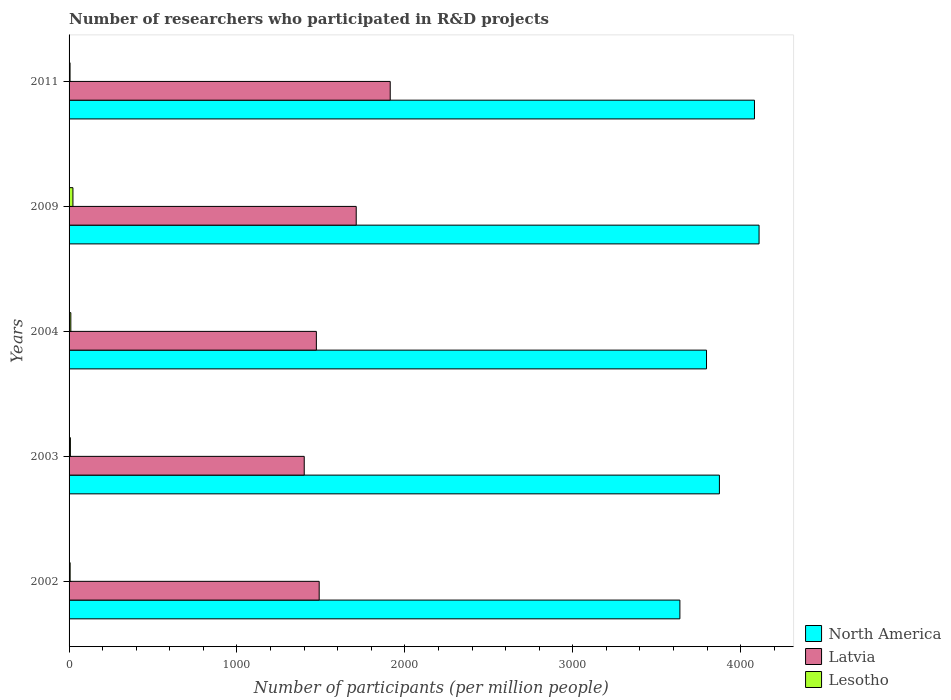How many groups of bars are there?
Ensure brevity in your answer.  5. Are the number of bars per tick equal to the number of legend labels?
Offer a terse response. Yes. Are the number of bars on each tick of the Y-axis equal?
Keep it short and to the point. Yes. How many bars are there on the 5th tick from the bottom?
Make the answer very short. 3. What is the label of the 3rd group of bars from the top?
Offer a very short reply. 2004. What is the number of researchers who participated in R&D projects in Latvia in 2004?
Your answer should be very brief. 1472.79. Across all years, what is the maximum number of researchers who participated in R&D projects in North America?
Your answer should be very brief. 4109.29. Across all years, what is the minimum number of researchers who participated in R&D projects in Lesotho?
Keep it short and to the point. 5.85. In which year was the number of researchers who participated in R&D projects in North America minimum?
Ensure brevity in your answer.  2002. What is the total number of researchers who participated in R&D projects in North America in the graph?
Provide a succinct answer. 1.95e+04. What is the difference between the number of researchers who participated in R&D projects in North America in 2004 and that in 2011?
Offer a very short reply. -285.58. What is the difference between the number of researchers who participated in R&D projects in North America in 2004 and the number of researchers who participated in R&D projects in Lesotho in 2009?
Provide a succinct answer. 3773.34. What is the average number of researchers who participated in R&D projects in Lesotho per year?
Your answer should be very brief. 10.72. In the year 2002, what is the difference between the number of researchers who participated in R&D projects in North America and number of researchers who participated in R&D projects in Latvia?
Give a very brief answer. 2148.18. What is the ratio of the number of researchers who participated in R&D projects in Lesotho in 2003 to that in 2009?
Provide a short and direct response. 0.34. What is the difference between the highest and the second highest number of researchers who participated in R&D projects in Latvia?
Ensure brevity in your answer.  202.43. What is the difference between the highest and the lowest number of researchers who participated in R&D projects in Latvia?
Provide a succinct answer. 512.06. In how many years, is the number of researchers who participated in R&D projects in Latvia greater than the average number of researchers who participated in R&D projects in Latvia taken over all years?
Your answer should be compact. 2. Are all the bars in the graph horizontal?
Your answer should be compact. Yes. How many years are there in the graph?
Keep it short and to the point. 5. What is the difference between two consecutive major ticks on the X-axis?
Make the answer very short. 1000. Does the graph contain any zero values?
Provide a short and direct response. No. How many legend labels are there?
Your response must be concise. 3. How are the legend labels stacked?
Give a very brief answer. Vertical. What is the title of the graph?
Offer a terse response. Number of researchers who participated in R&D projects. What is the label or title of the X-axis?
Provide a succinct answer. Number of participants (per million people). What is the Number of participants (per million people) in North America in 2002?
Offer a terse response. 3637.78. What is the Number of participants (per million people) of Latvia in 2002?
Provide a succinct answer. 1489.6. What is the Number of participants (per million people) of Lesotho in 2002?
Provide a succinct answer. 6.36. What is the Number of participants (per million people) of North America in 2003?
Ensure brevity in your answer.  3873.15. What is the Number of participants (per million people) in Latvia in 2003?
Ensure brevity in your answer.  1400.56. What is the Number of participants (per million people) in Lesotho in 2003?
Give a very brief answer. 7.9. What is the Number of participants (per million people) in North America in 2004?
Offer a terse response. 3796.35. What is the Number of participants (per million people) in Latvia in 2004?
Offer a terse response. 1472.79. What is the Number of participants (per million people) in Lesotho in 2004?
Your response must be concise. 10.46. What is the Number of participants (per million people) of North America in 2009?
Give a very brief answer. 4109.29. What is the Number of participants (per million people) in Latvia in 2009?
Keep it short and to the point. 1710.19. What is the Number of participants (per million people) in Lesotho in 2009?
Provide a succinct answer. 23.01. What is the Number of participants (per million people) in North America in 2011?
Ensure brevity in your answer.  4081.94. What is the Number of participants (per million people) of Latvia in 2011?
Your response must be concise. 1912.62. What is the Number of participants (per million people) in Lesotho in 2011?
Give a very brief answer. 5.85. Across all years, what is the maximum Number of participants (per million people) of North America?
Keep it short and to the point. 4109.29. Across all years, what is the maximum Number of participants (per million people) in Latvia?
Your answer should be compact. 1912.62. Across all years, what is the maximum Number of participants (per million people) in Lesotho?
Your answer should be compact. 23.01. Across all years, what is the minimum Number of participants (per million people) in North America?
Offer a very short reply. 3637.78. Across all years, what is the minimum Number of participants (per million people) in Latvia?
Keep it short and to the point. 1400.56. Across all years, what is the minimum Number of participants (per million people) in Lesotho?
Make the answer very short. 5.85. What is the total Number of participants (per million people) of North America in the graph?
Your answer should be compact. 1.95e+04. What is the total Number of participants (per million people) of Latvia in the graph?
Ensure brevity in your answer.  7985.76. What is the total Number of participants (per million people) in Lesotho in the graph?
Ensure brevity in your answer.  53.59. What is the difference between the Number of participants (per million people) in North America in 2002 and that in 2003?
Your answer should be very brief. -235.37. What is the difference between the Number of participants (per million people) in Latvia in 2002 and that in 2003?
Your response must be concise. 89.04. What is the difference between the Number of participants (per million people) of Lesotho in 2002 and that in 2003?
Give a very brief answer. -1.54. What is the difference between the Number of participants (per million people) in North America in 2002 and that in 2004?
Offer a terse response. -158.58. What is the difference between the Number of participants (per million people) of Latvia in 2002 and that in 2004?
Keep it short and to the point. 16.81. What is the difference between the Number of participants (per million people) of Lesotho in 2002 and that in 2004?
Make the answer very short. -4.1. What is the difference between the Number of participants (per million people) of North America in 2002 and that in 2009?
Ensure brevity in your answer.  -471.52. What is the difference between the Number of participants (per million people) of Latvia in 2002 and that in 2009?
Give a very brief answer. -220.59. What is the difference between the Number of participants (per million people) in Lesotho in 2002 and that in 2009?
Provide a short and direct response. -16.65. What is the difference between the Number of participants (per million people) of North America in 2002 and that in 2011?
Give a very brief answer. -444.16. What is the difference between the Number of participants (per million people) of Latvia in 2002 and that in 2011?
Keep it short and to the point. -423.02. What is the difference between the Number of participants (per million people) in Lesotho in 2002 and that in 2011?
Your response must be concise. 0.51. What is the difference between the Number of participants (per million people) of North America in 2003 and that in 2004?
Offer a very short reply. 76.79. What is the difference between the Number of participants (per million people) in Latvia in 2003 and that in 2004?
Your answer should be compact. -72.24. What is the difference between the Number of participants (per million people) in Lesotho in 2003 and that in 2004?
Make the answer very short. -2.56. What is the difference between the Number of participants (per million people) of North America in 2003 and that in 2009?
Provide a short and direct response. -236.14. What is the difference between the Number of participants (per million people) of Latvia in 2003 and that in 2009?
Offer a very short reply. -309.63. What is the difference between the Number of participants (per million people) of Lesotho in 2003 and that in 2009?
Provide a short and direct response. -15.11. What is the difference between the Number of participants (per million people) in North America in 2003 and that in 2011?
Your answer should be very brief. -208.79. What is the difference between the Number of participants (per million people) in Latvia in 2003 and that in 2011?
Your answer should be compact. -512.06. What is the difference between the Number of participants (per million people) in Lesotho in 2003 and that in 2011?
Your answer should be compact. 2.05. What is the difference between the Number of participants (per million people) of North America in 2004 and that in 2009?
Give a very brief answer. -312.94. What is the difference between the Number of participants (per million people) of Latvia in 2004 and that in 2009?
Make the answer very short. -237.4. What is the difference between the Number of participants (per million people) of Lesotho in 2004 and that in 2009?
Keep it short and to the point. -12.55. What is the difference between the Number of participants (per million people) of North America in 2004 and that in 2011?
Offer a terse response. -285.58. What is the difference between the Number of participants (per million people) in Latvia in 2004 and that in 2011?
Your response must be concise. -439.83. What is the difference between the Number of participants (per million people) of Lesotho in 2004 and that in 2011?
Ensure brevity in your answer.  4.61. What is the difference between the Number of participants (per million people) in North America in 2009 and that in 2011?
Provide a short and direct response. 27.36. What is the difference between the Number of participants (per million people) of Latvia in 2009 and that in 2011?
Your answer should be very brief. -202.43. What is the difference between the Number of participants (per million people) of Lesotho in 2009 and that in 2011?
Your answer should be compact. 17.16. What is the difference between the Number of participants (per million people) in North America in 2002 and the Number of participants (per million people) in Latvia in 2003?
Give a very brief answer. 2237.22. What is the difference between the Number of participants (per million people) of North America in 2002 and the Number of participants (per million people) of Lesotho in 2003?
Keep it short and to the point. 3629.88. What is the difference between the Number of participants (per million people) in Latvia in 2002 and the Number of participants (per million people) in Lesotho in 2003?
Your answer should be very brief. 1481.7. What is the difference between the Number of participants (per million people) in North America in 2002 and the Number of participants (per million people) in Latvia in 2004?
Give a very brief answer. 2164.98. What is the difference between the Number of participants (per million people) in North America in 2002 and the Number of participants (per million people) in Lesotho in 2004?
Make the answer very short. 3627.32. What is the difference between the Number of participants (per million people) in Latvia in 2002 and the Number of participants (per million people) in Lesotho in 2004?
Give a very brief answer. 1479.14. What is the difference between the Number of participants (per million people) in North America in 2002 and the Number of participants (per million people) in Latvia in 2009?
Give a very brief answer. 1927.59. What is the difference between the Number of participants (per million people) in North America in 2002 and the Number of participants (per million people) in Lesotho in 2009?
Provide a succinct answer. 3614.77. What is the difference between the Number of participants (per million people) in Latvia in 2002 and the Number of participants (per million people) in Lesotho in 2009?
Provide a succinct answer. 1466.59. What is the difference between the Number of participants (per million people) in North America in 2002 and the Number of participants (per million people) in Latvia in 2011?
Your answer should be compact. 1725.16. What is the difference between the Number of participants (per million people) in North America in 2002 and the Number of participants (per million people) in Lesotho in 2011?
Ensure brevity in your answer.  3631.92. What is the difference between the Number of participants (per million people) of Latvia in 2002 and the Number of participants (per million people) of Lesotho in 2011?
Offer a terse response. 1483.75. What is the difference between the Number of participants (per million people) in North America in 2003 and the Number of participants (per million people) in Latvia in 2004?
Make the answer very short. 2400.36. What is the difference between the Number of participants (per million people) of North America in 2003 and the Number of participants (per million people) of Lesotho in 2004?
Provide a succinct answer. 3862.69. What is the difference between the Number of participants (per million people) of Latvia in 2003 and the Number of participants (per million people) of Lesotho in 2004?
Your answer should be compact. 1390.1. What is the difference between the Number of participants (per million people) in North America in 2003 and the Number of participants (per million people) in Latvia in 2009?
Provide a short and direct response. 2162.96. What is the difference between the Number of participants (per million people) of North America in 2003 and the Number of participants (per million people) of Lesotho in 2009?
Give a very brief answer. 3850.14. What is the difference between the Number of participants (per million people) in Latvia in 2003 and the Number of participants (per million people) in Lesotho in 2009?
Give a very brief answer. 1377.55. What is the difference between the Number of participants (per million people) of North America in 2003 and the Number of participants (per million people) of Latvia in 2011?
Provide a succinct answer. 1960.53. What is the difference between the Number of participants (per million people) in North America in 2003 and the Number of participants (per million people) in Lesotho in 2011?
Keep it short and to the point. 3867.3. What is the difference between the Number of participants (per million people) of Latvia in 2003 and the Number of participants (per million people) of Lesotho in 2011?
Offer a terse response. 1394.7. What is the difference between the Number of participants (per million people) in North America in 2004 and the Number of participants (per million people) in Latvia in 2009?
Offer a very short reply. 2086.16. What is the difference between the Number of participants (per million people) of North America in 2004 and the Number of participants (per million people) of Lesotho in 2009?
Your answer should be compact. 3773.34. What is the difference between the Number of participants (per million people) of Latvia in 2004 and the Number of participants (per million people) of Lesotho in 2009?
Your answer should be compact. 1449.78. What is the difference between the Number of participants (per million people) of North America in 2004 and the Number of participants (per million people) of Latvia in 2011?
Keep it short and to the point. 1883.73. What is the difference between the Number of participants (per million people) of North America in 2004 and the Number of participants (per million people) of Lesotho in 2011?
Offer a very short reply. 3790.5. What is the difference between the Number of participants (per million people) in Latvia in 2004 and the Number of participants (per million people) in Lesotho in 2011?
Keep it short and to the point. 1466.94. What is the difference between the Number of participants (per million people) of North America in 2009 and the Number of participants (per million people) of Latvia in 2011?
Provide a succinct answer. 2196.67. What is the difference between the Number of participants (per million people) of North America in 2009 and the Number of participants (per million people) of Lesotho in 2011?
Give a very brief answer. 4103.44. What is the difference between the Number of participants (per million people) in Latvia in 2009 and the Number of participants (per million people) in Lesotho in 2011?
Provide a succinct answer. 1704.34. What is the average Number of participants (per million people) in North America per year?
Your answer should be very brief. 3899.7. What is the average Number of participants (per million people) of Latvia per year?
Give a very brief answer. 1597.15. What is the average Number of participants (per million people) in Lesotho per year?
Your response must be concise. 10.72. In the year 2002, what is the difference between the Number of participants (per million people) in North America and Number of participants (per million people) in Latvia?
Offer a terse response. 2148.18. In the year 2002, what is the difference between the Number of participants (per million people) in North America and Number of participants (per million people) in Lesotho?
Make the answer very short. 3631.41. In the year 2002, what is the difference between the Number of participants (per million people) in Latvia and Number of participants (per million people) in Lesotho?
Offer a terse response. 1483.23. In the year 2003, what is the difference between the Number of participants (per million people) in North America and Number of participants (per million people) in Latvia?
Ensure brevity in your answer.  2472.59. In the year 2003, what is the difference between the Number of participants (per million people) of North America and Number of participants (per million people) of Lesotho?
Ensure brevity in your answer.  3865.25. In the year 2003, what is the difference between the Number of participants (per million people) of Latvia and Number of participants (per million people) of Lesotho?
Give a very brief answer. 1392.66. In the year 2004, what is the difference between the Number of participants (per million people) in North America and Number of participants (per million people) in Latvia?
Your response must be concise. 2323.56. In the year 2004, what is the difference between the Number of participants (per million people) of North America and Number of participants (per million people) of Lesotho?
Your response must be concise. 3785.89. In the year 2004, what is the difference between the Number of participants (per million people) in Latvia and Number of participants (per million people) in Lesotho?
Your answer should be very brief. 1462.33. In the year 2009, what is the difference between the Number of participants (per million people) in North America and Number of participants (per million people) in Latvia?
Ensure brevity in your answer.  2399.1. In the year 2009, what is the difference between the Number of participants (per million people) in North America and Number of participants (per million people) in Lesotho?
Your response must be concise. 4086.28. In the year 2009, what is the difference between the Number of participants (per million people) in Latvia and Number of participants (per million people) in Lesotho?
Provide a succinct answer. 1687.18. In the year 2011, what is the difference between the Number of participants (per million people) in North America and Number of participants (per million people) in Latvia?
Your response must be concise. 2169.32. In the year 2011, what is the difference between the Number of participants (per million people) in North America and Number of participants (per million people) in Lesotho?
Offer a terse response. 4076.08. In the year 2011, what is the difference between the Number of participants (per million people) in Latvia and Number of participants (per million people) in Lesotho?
Your answer should be compact. 1906.77. What is the ratio of the Number of participants (per million people) in North America in 2002 to that in 2003?
Your answer should be very brief. 0.94. What is the ratio of the Number of participants (per million people) of Latvia in 2002 to that in 2003?
Offer a terse response. 1.06. What is the ratio of the Number of participants (per million people) of Lesotho in 2002 to that in 2003?
Your answer should be compact. 0.81. What is the ratio of the Number of participants (per million people) in North America in 2002 to that in 2004?
Offer a terse response. 0.96. What is the ratio of the Number of participants (per million people) of Latvia in 2002 to that in 2004?
Give a very brief answer. 1.01. What is the ratio of the Number of participants (per million people) of Lesotho in 2002 to that in 2004?
Your answer should be very brief. 0.61. What is the ratio of the Number of participants (per million people) in North America in 2002 to that in 2009?
Ensure brevity in your answer.  0.89. What is the ratio of the Number of participants (per million people) of Latvia in 2002 to that in 2009?
Provide a short and direct response. 0.87. What is the ratio of the Number of participants (per million people) in Lesotho in 2002 to that in 2009?
Offer a terse response. 0.28. What is the ratio of the Number of participants (per million people) of North America in 2002 to that in 2011?
Give a very brief answer. 0.89. What is the ratio of the Number of participants (per million people) in Latvia in 2002 to that in 2011?
Ensure brevity in your answer.  0.78. What is the ratio of the Number of participants (per million people) in Lesotho in 2002 to that in 2011?
Your answer should be very brief. 1.09. What is the ratio of the Number of participants (per million people) in North America in 2003 to that in 2004?
Offer a very short reply. 1.02. What is the ratio of the Number of participants (per million people) of Latvia in 2003 to that in 2004?
Make the answer very short. 0.95. What is the ratio of the Number of participants (per million people) of Lesotho in 2003 to that in 2004?
Ensure brevity in your answer.  0.76. What is the ratio of the Number of participants (per million people) of North America in 2003 to that in 2009?
Provide a short and direct response. 0.94. What is the ratio of the Number of participants (per million people) in Latvia in 2003 to that in 2009?
Keep it short and to the point. 0.82. What is the ratio of the Number of participants (per million people) in Lesotho in 2003 to that in 2009?
Give a very brief answer. 0.34. What is the ratio of the Number of participants (per million people) in North America in 2003 to that in 2011?
Ensure brevity in your answer.  0.95. What is the ratio of the Number of participants (per million people) in Latvia in 2003 to that in 2011?
Your answer should be compact. 0.73. What is the ratio of the Number of participants (per million people) in Lesotho in 2003 to that in 2011?
Provide a short and direct response. 1.35. What is the ratio of the Number of participants (per million people) in North America in 2004 to that in 2009?
Your answer should be very brief. 0.92. What is the ratio of the Number of participants (per million people) of Latvia in 2004 to that in 2009?
Your response must be concise. 0.86. What is the ratio of the Number of participants (per million people) in Lesotho in 2004 to that in 2009?
Your response must be concise. 0.45. What is the ratio of the Number of participants (per million people) in North America in 2004 to that in 2011?
Make the answer very short. 0.93. What is the ratio of the Number of participants (per million people) in Latvia in 2004 to that in 2011?
Your answer should be very brief. 0.77. What is the ratio of the Number of participants (per million people) in Lesotho in 2004 to that in 2011?
Provide a succinct answer. 1.79. What is the ratio of the Number of participants (per million people) in North America in 2009 to that in 2011?
Offer a terse response. 1.01. What is the ratio of the Number of participants (per million people) in Latvia in 2009 to that in 2011?
Make the answer very short. 0.89. What is the ratio of the Number of participants (per million people) in Lesotho in 2009 to that in 2011?
Your answer should be compact. 3.93. What is the difference between the highest and the second highest Number of participants (per million people) in North America?
Keep it short and to the point. 27.36. What is the difference between the highest and the second highest Number of participants (per million people) in Latvia?
Offer a very short reply. 202.43. What is the difference between the highest and the second highest Number of participants (per million people) in Lesotho?
Your answer should be compact. 12.55. What is the difference between the highest and the lowest Number of participants (per million people) of North America?
Offer a terse response. 471.52. What is the difference between the highest and the lowest Number of participants (per million people) in Latvia?
Keep it short and to the point. 512.06. What is the difference between the highest and the lowest Number of participants (per million people) in Lesotho?
Provide a short and direct response. 17.16. 